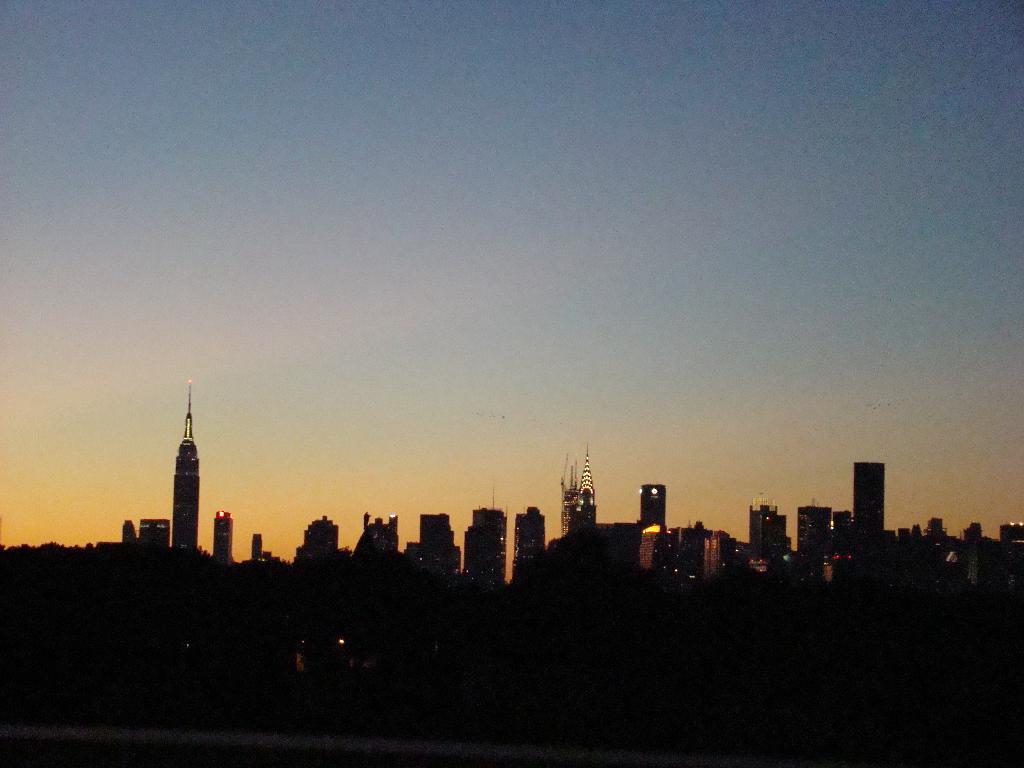Please provide a concise description of this image. This is the dark picture of a place where we can see so many buildings and trees. 